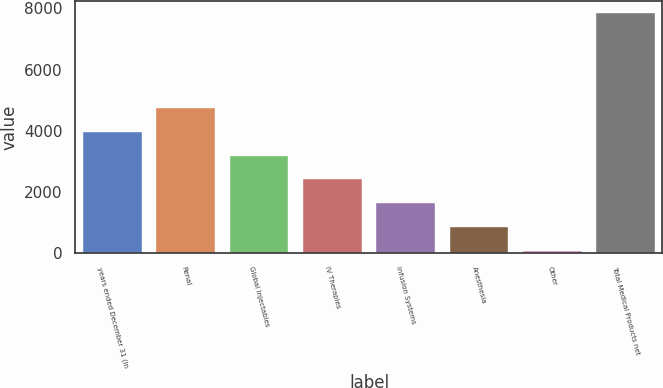<chart> <loc_0><loc_0><loc_500><loc_500><bar_chart><fcel>years ended December 31 (in<fcel>Renal<fcel>Global Injectables<fcel>IV Therapies<fcel>Infusion Systems<fcel>Anesthesia<fcel>Other<fcel>Total Medical Products net<nl><fcel>3953<fcel>4730.4<fcel>3175.6<fcel>2398.2<fcel>1620.8<fcel>843.4<fcel>66<fcel>7840<nl></chart> 